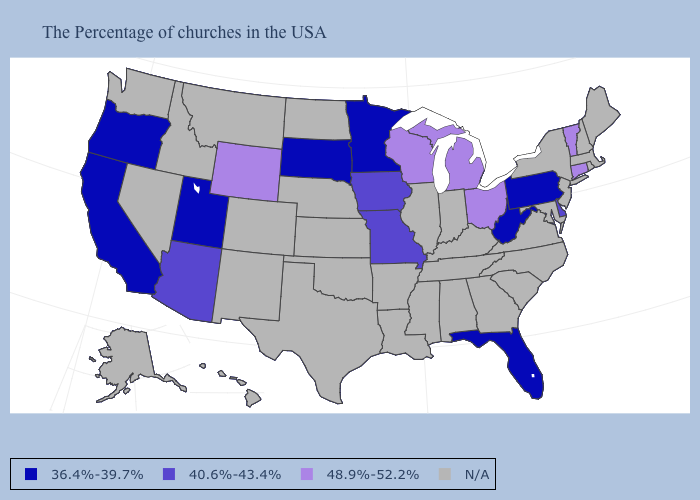What is the value of Oklahoma?
Be succinct. N/A. Among the states that border Nebraska , which have the lowest value?
Write a very short answer. South Dakota. Among the states that border Alabama , which have the lowest value?
Short answer required. Florida. What is the value of South Carolina?
Give a very brief answer. N/A. Name the states that have a value in the range 36.4%-39.7%?
Answer briefly. Pennsylvania, West Virginia, Florida, Minnesota, South Dakota, Utah, California, Oregon. Among the states that border Iowa , does Minnesota have the lowest value?
Write a very short answer. Yes. What is the lowest value in states that border South Dakota?
Answer briefly. 36.4%-39.7%. What is the value of Pennsylvania?
Keep it brief. 36.4%-39.7%. What is the value of Nebraska?
Write a very short answer. N/A. Among the states that border New Jersey , which have the lowest value?
Answer briefly. Pennsylvania. Which states have the lowest value in the USA?
Write a very short answer. Pennsylvania, West Virginia, Florida, Minnesota, South Dakota, Utah, California, Oregon. What is the lowest value in the USA?
Keep it brief. 36.4%-39.7%. What is the value of Hawaii?
Concise answer only. N/A. 